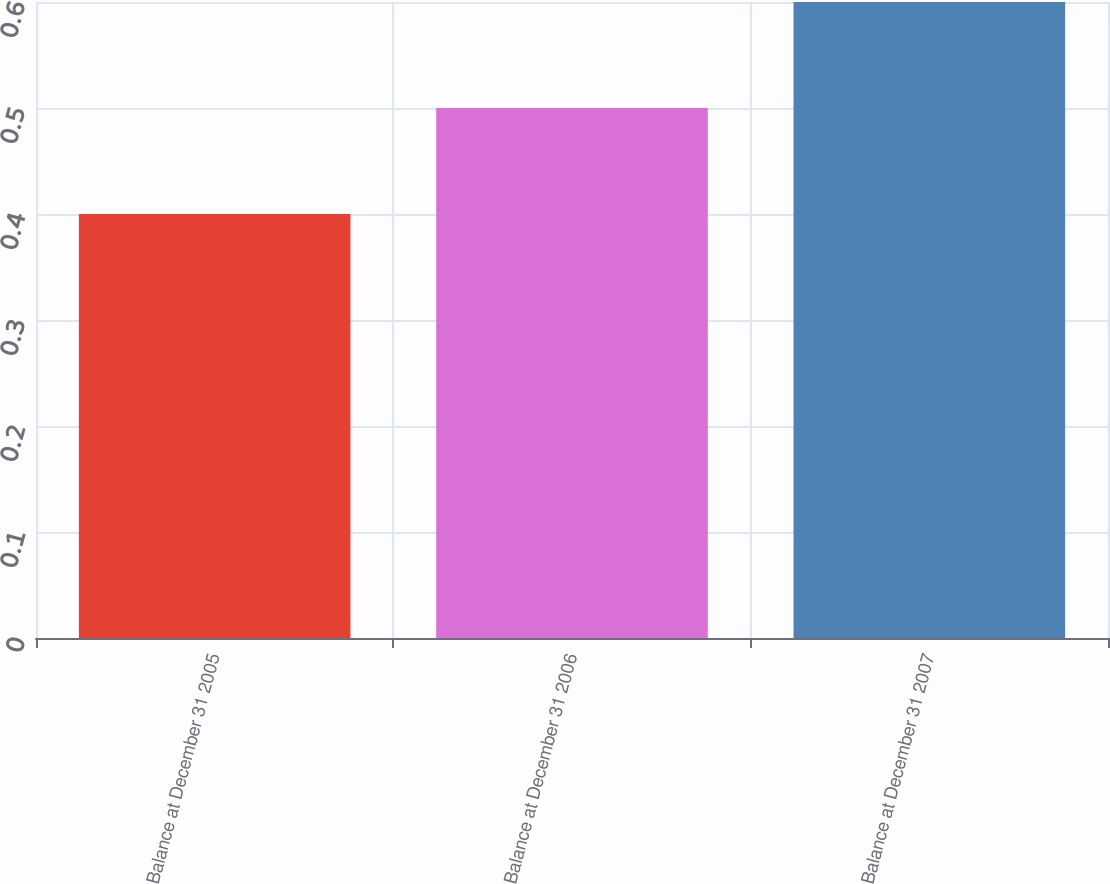<chart> <loc_0><loc_0><loc_500><loc_500><bar_chart><fcel>Balance at December 31 2005<fcel>Balance at December 31 2006<fcel>Balance at December 31 2007<nl><fcel>0.4<fcel>0.5<fcel>0.6<nl></chart> 